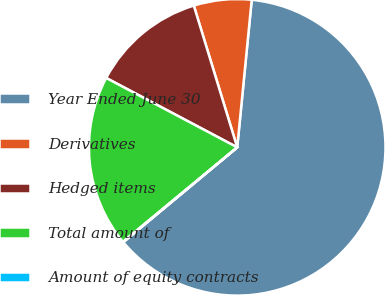Convert chart. <chart><loc_0><loc_0><loc_500><loc_500><pie_chart><fcel>Year Ended June 30<fcel>Derivatives<fcel>Hedged items<fcel>Total amount of<fcel>Amount of equity contracts<nl><fcel>62.39%<fcel>6.29%<fcel>12.52%<fcel>18.75%<fcel>0.05%<nl></chart> 